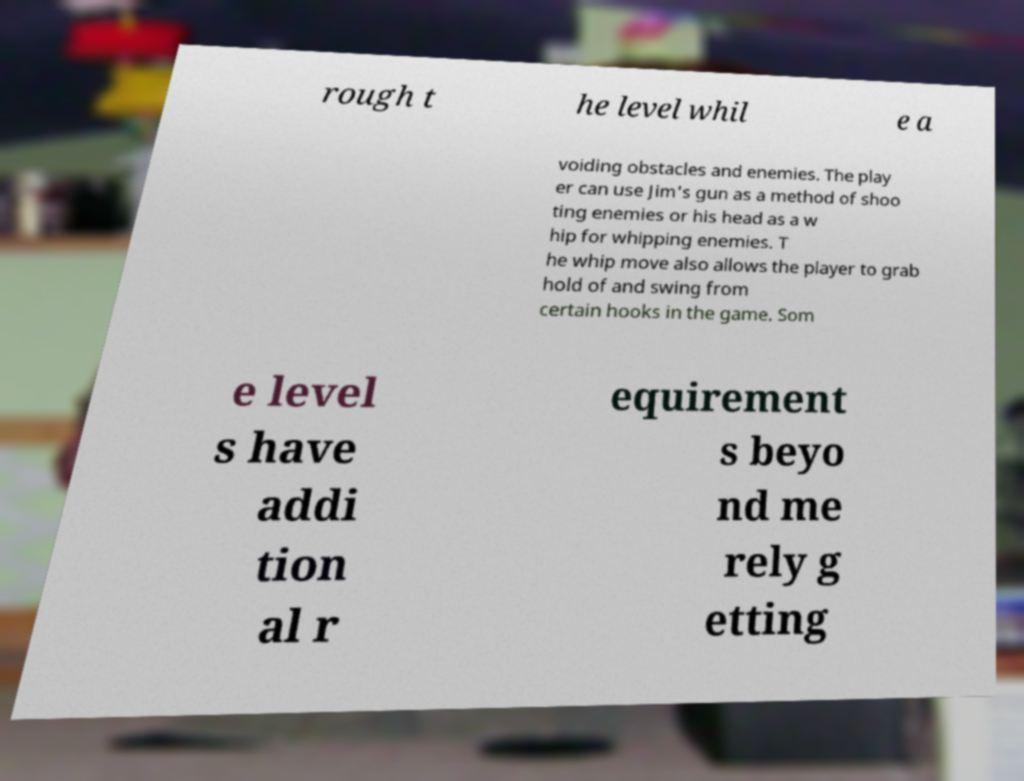For documentation purposes, I need the text within this image transcribed. Could you provide that? rough t he level whil e a voiding obstacles and enemies. The play er can use Jim's gun as a method of shoo ting enemies or his head as a w hip for whipping enemies. T he whip move also allows the player to grab hold of and swing from certain hooks in the game. Som e level s have addi tion al r equirement s beyo nd me rely g etting 